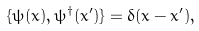<formula> <loc_0><loc_0><loc_500><loc_500>\{ \psi ( { x } ) , \psi ^ { \dag } ( { x } ^ { \prime } ) \} = \delta ( { x } - { x } ^ { \prime } ) ,</formula> 